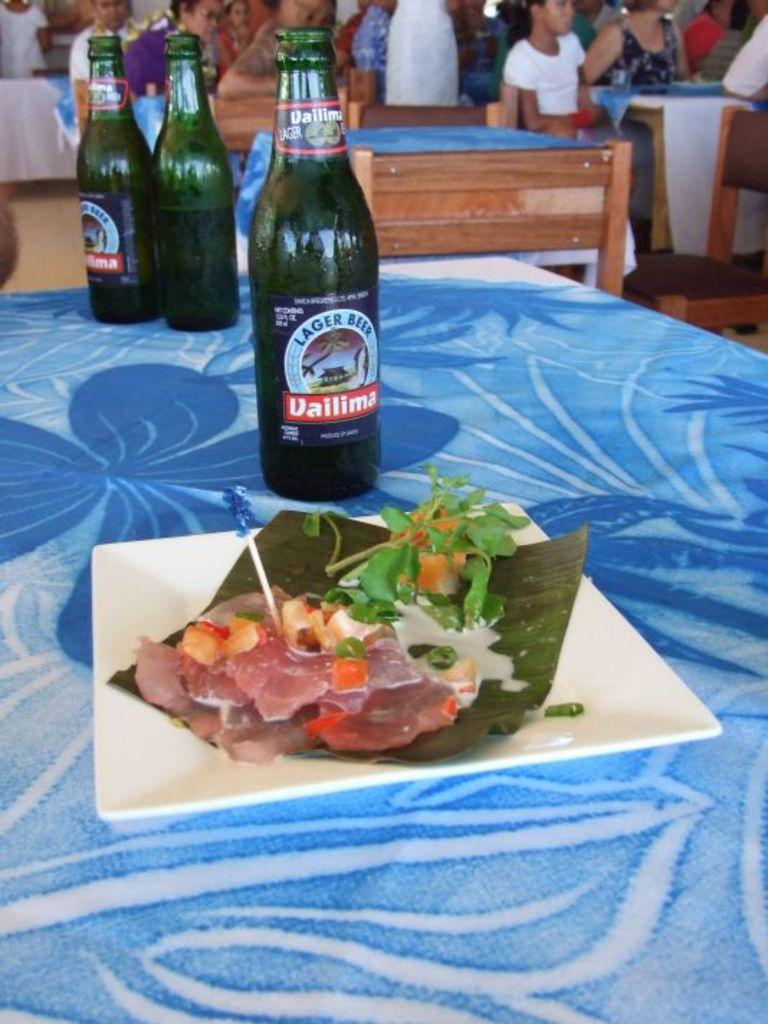What are the people in the image doing? The people in the image are sitting. What is on the table in the image? There is a table in the image with food, tissues, and bottles on it. What might be used for cleaning or wiping in the image? Tissues are present on the table for cleaning or wiping. What type of crime is being committed in the image? There is no crime being committed in the image; it shows people sitting at a table with food, tissues, and bottles. What game is being played in the image? There is no game being played in the image; it shows people sitting at a table with food, tissues, and bottles. 